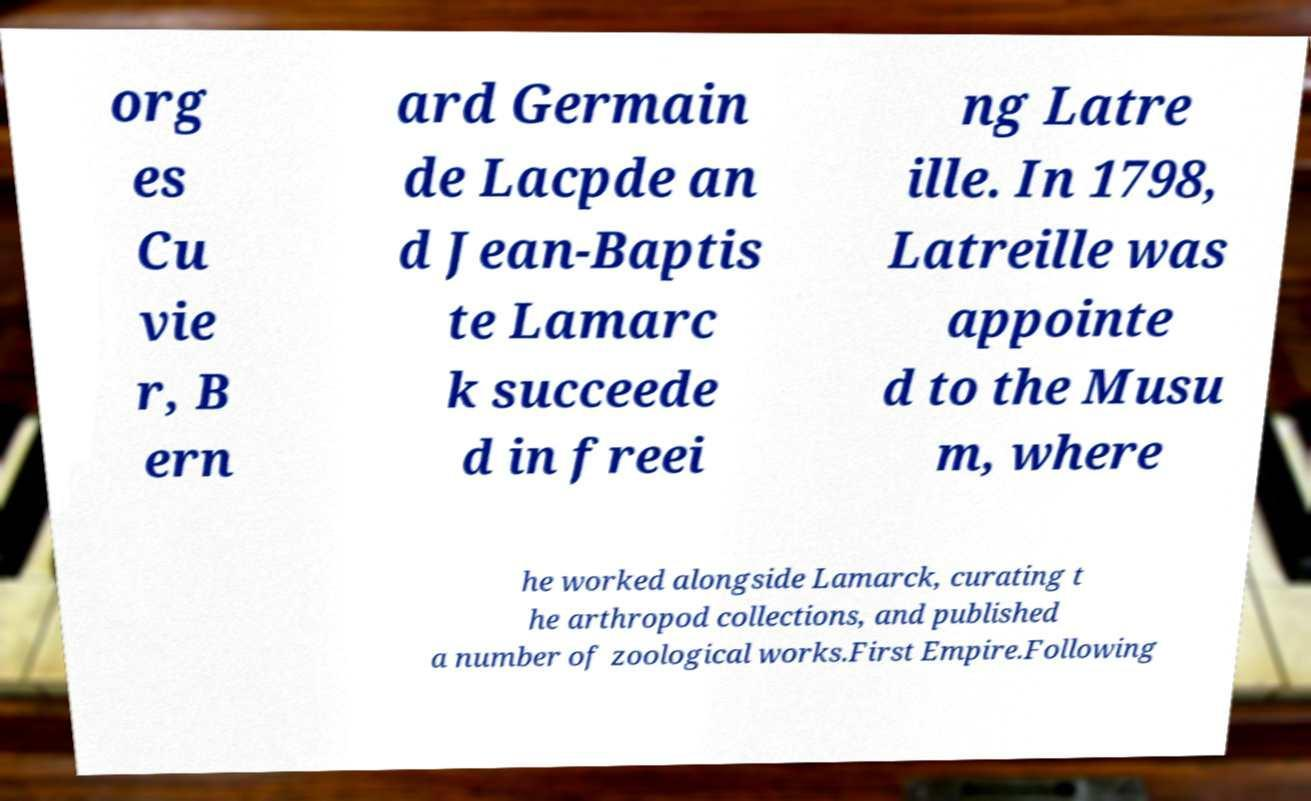Could you assist in decoding the text presented in this image and type it out clearly? org es Cu vie r, B ern ard Germain de Lacpde an d Jean-Baptis te Lamarc k succeede d in freei ng Latre ille. In 1798, Latreille was appointe d to the Musu m, where he worked alongside Lamarck, curating t he arthropod collections, and published a number of zoological works.First Empire.Following 